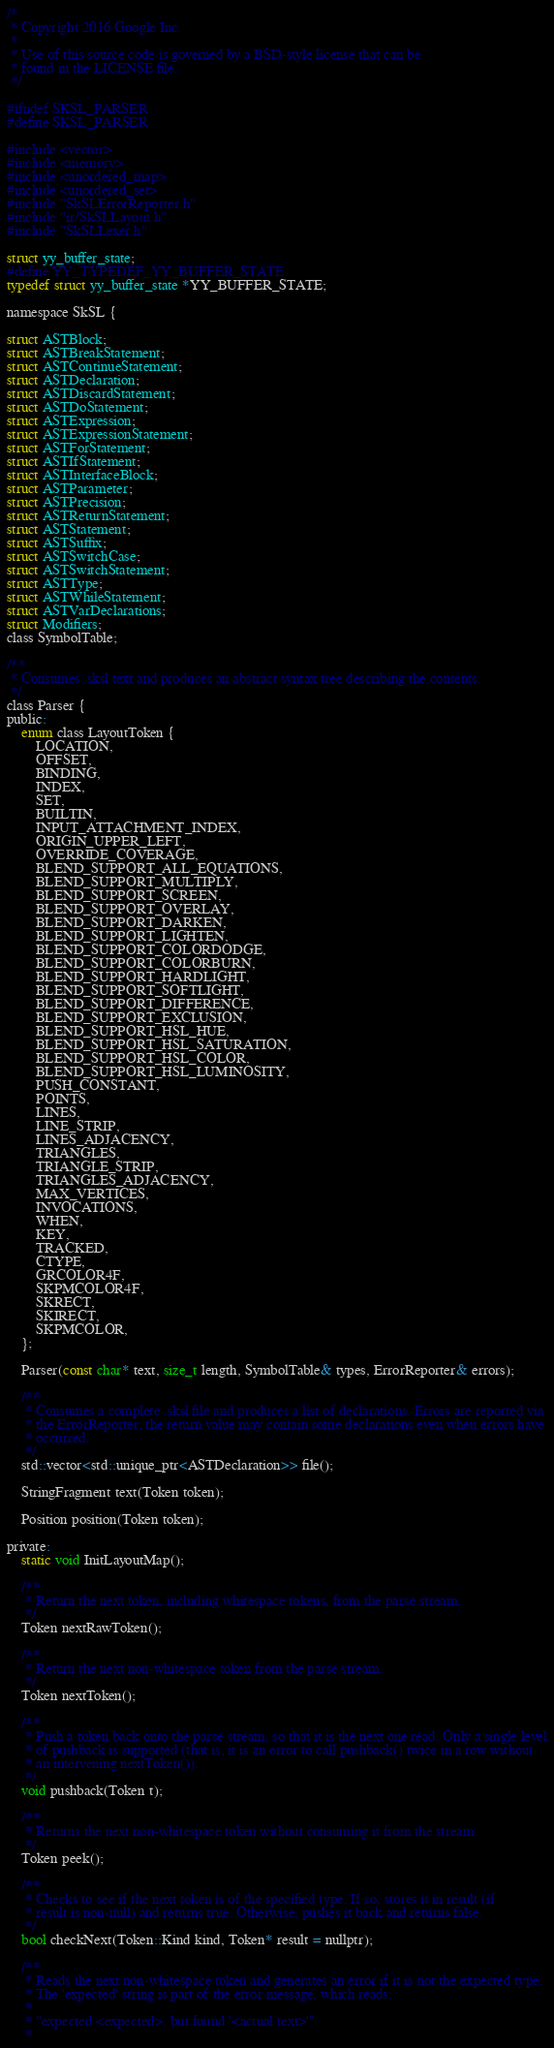Convert code to text. <code><loc_0><loc_0><loc_500><loc_500><_C_>/*
 * Copyright 2016 Google Inc.
 *
 * Use of this source code is governed by a BSD-style license that can be
 * found in the LICENSE file.
 */

#ifndef SKSL_PARSER
#define SKSL_PARSER

#include <vector>
#include <memory>
#include <unordered_map>
#include <unordered_set>
#include "SkSLErrorReporter.h"
#include "ir/SkSLLayout.h"
#include "SkSLLexer.h"

struct yy_buffer_state;
#define YY_TYPEDEF_YY_BUFFER_STATE
typedef struct yy_buffer_state *YY_BUFFER_STATE;

namespace SkSL {

struct ASTBlock;
struct ASTBreakStatement;
struct ASTContinueStatement;
struct ASTDeclaration;
struct ASTDiscardStatement;
struct ASTDoStatement;
struct ASTExpression;
struct ASTExpressionStatement;
struct ASTForStatement;
struct ASTIfStatement;
struct ASTInterfaceBlock;
struct ASTParameter;
struct ASTPrecision;
struct ASTReturnStatement;
struct ASTStatement;
struct ASTSuffix;
struct ASTSwitchCase;
struct ASTSwitchStatement;
struct ASTType;
struct ASTWhileStatement;
struct ASTVarDeclarations;
struct Modifiers;
class SymbolTable;

/**
 * Consumes .sksl text and produces an abstract syntax tree describing the contents.
 */
class Parser {
public:
    enum class LayoutToken {
        LOCATION,
        OFFSET,
        BINDING,
        INDEX,
        SET,
        BUILTIN,
        INPUT_ATTACHMENT_INDEX,
        ORIGIN_UPPER_LEFT,
        OVERRIDE_COVERAGE,
        BLEND_SUPPORT_ALL_EQUATIONS,
        BLEND_SUPPORT_MULTIPLY,
        BLEND_SUPPORT_SCREEN,
        BLEND_SUPPORT_OVERLAY,
        BLEND_SUPPORT_DARKEN,
        BLEND_SUPPORT_LIGHTEN,
        BLEND_SUPPORT_COLORDODGE,
        BLEND_SUPPORT_COLORBURN,
        BLEND_SUPPORT_HARDLIGHT,
        BLEND_SUPPORT_SOFTLIGHT,
        BLEND_SUPPORT_DIFFERENCE,
        BLEND_SUPPORT_EXCLUSION,
        BLEND_SUPPORT_HSL_HUE,
        BLEND_SUPPORT_HSL_SATURATION,
        BLEND_SUPPORT_HSL_COLOR,
        BLEND_SUPPORT_HSL_LUMINOSITY,
        PUSH_CONSTANT,
        POINTS,
        LINES,
        LINE_STRIP,
        LINES_ADJACENCY,
        TRIANGLES,
        TRIANGLE_STRIP,
        TRIANGLES_ADJACENCY,
        MAX_VERTICES,
        INVOCATIONS,
        WHEN,
        KEY,
        TRACKED,
        CTYPE,
        GRCOLOR4F,
        SKPMCOLOR4F,
        SKRECT,
        SKIRECT,
        SKPMCOLOR,
    };

    Parser(const char* text, size_t length, SymbolTable& types, ErrorReporter& errors);

    /**
     * Consumes a complete .sksl file and produces a list of declarations. Errors are reported via
     * the ErrorReporter; the return value may contain some declarations even when errors have
     * occurred.
     */
    std::vector<std::unique_ptr<ASTDeclaration>> file();

    StringFragment text(Token token);

    Position position(Token token);

private:
    static void InitLayoutMap();

    /**
     * Return the next token, including whitespace tokens, from the parse stream.
     */
    Token nextRawToken();

    /**
     * Return the next non-whitespace token from the parse stream.
     */
    Token nextToken();

    /**
     * Push a token back onto the parse stream, so that it is the next one read. Only a single level
     * of pushback is supported (that is, it is an error to call pushback() twice in a row without
     * an intervening nextToken()).
     */
    void pushback(Token t);

    /**
     * Returns the next non-whitespace token without consuming it from the stream.
     */
    Token peek();

    /**
     * Checks to see if the next token is of the specified type. If so, stores it in result (if
     * result is non-null) and returns true. Otherwise, pushes it back and returns false.
     */
    bool checkNext(Token::Kind kind, Token* result = nullptr);

    /**
     * Reads the next non-whitespace token and generates an error if it is not the expected type.
     * The 'expected' string is part of the error message, which reads:
     *
     * "expected <expected>, but found '<actual text>'"
     *</code> 